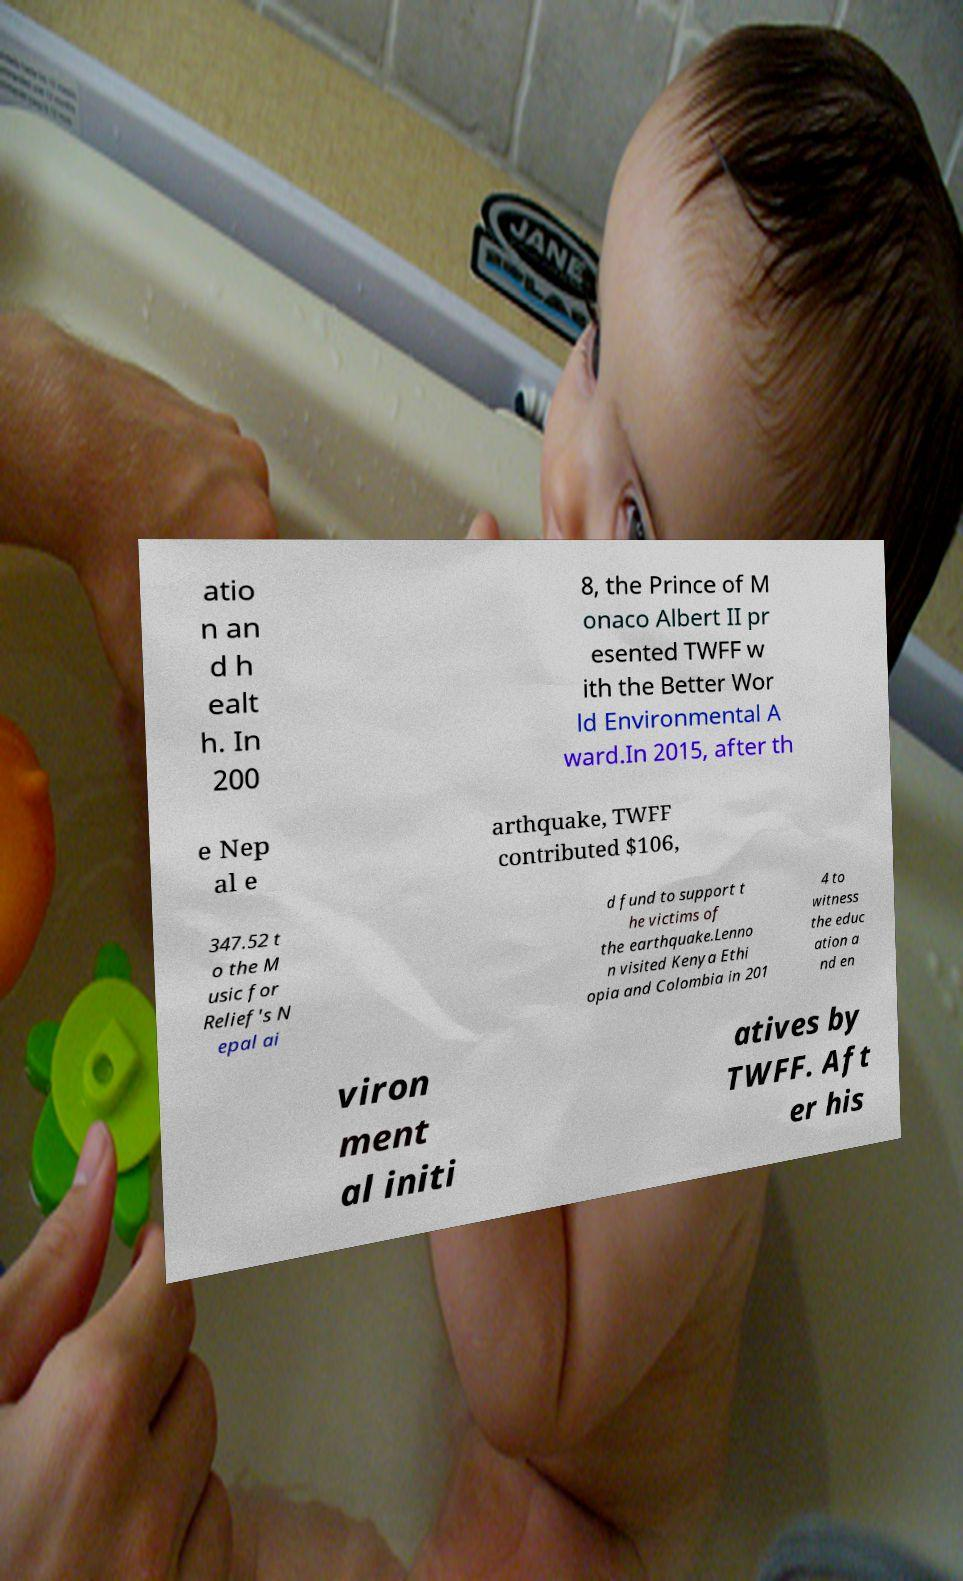What messages or text are displayed in this image? I need them in a readable, typed format. atio n an d h ealt h. In 200 8, the Prince of M onaco Albert II pr esented TWFF w ith the Better Wor ld Environmental A ward.In 2015, after th e Nep al e arthquake, TWFF contributed $106, 347.52 t o the M usic for Relief's N epal ai d fund to support t he victims of the earthquake.Lenno n visited Kenya Ethi opia and Colombia in 201 4 to witness the educ ation a nd en viron ment al initi atives by TWFF. Aft er his 